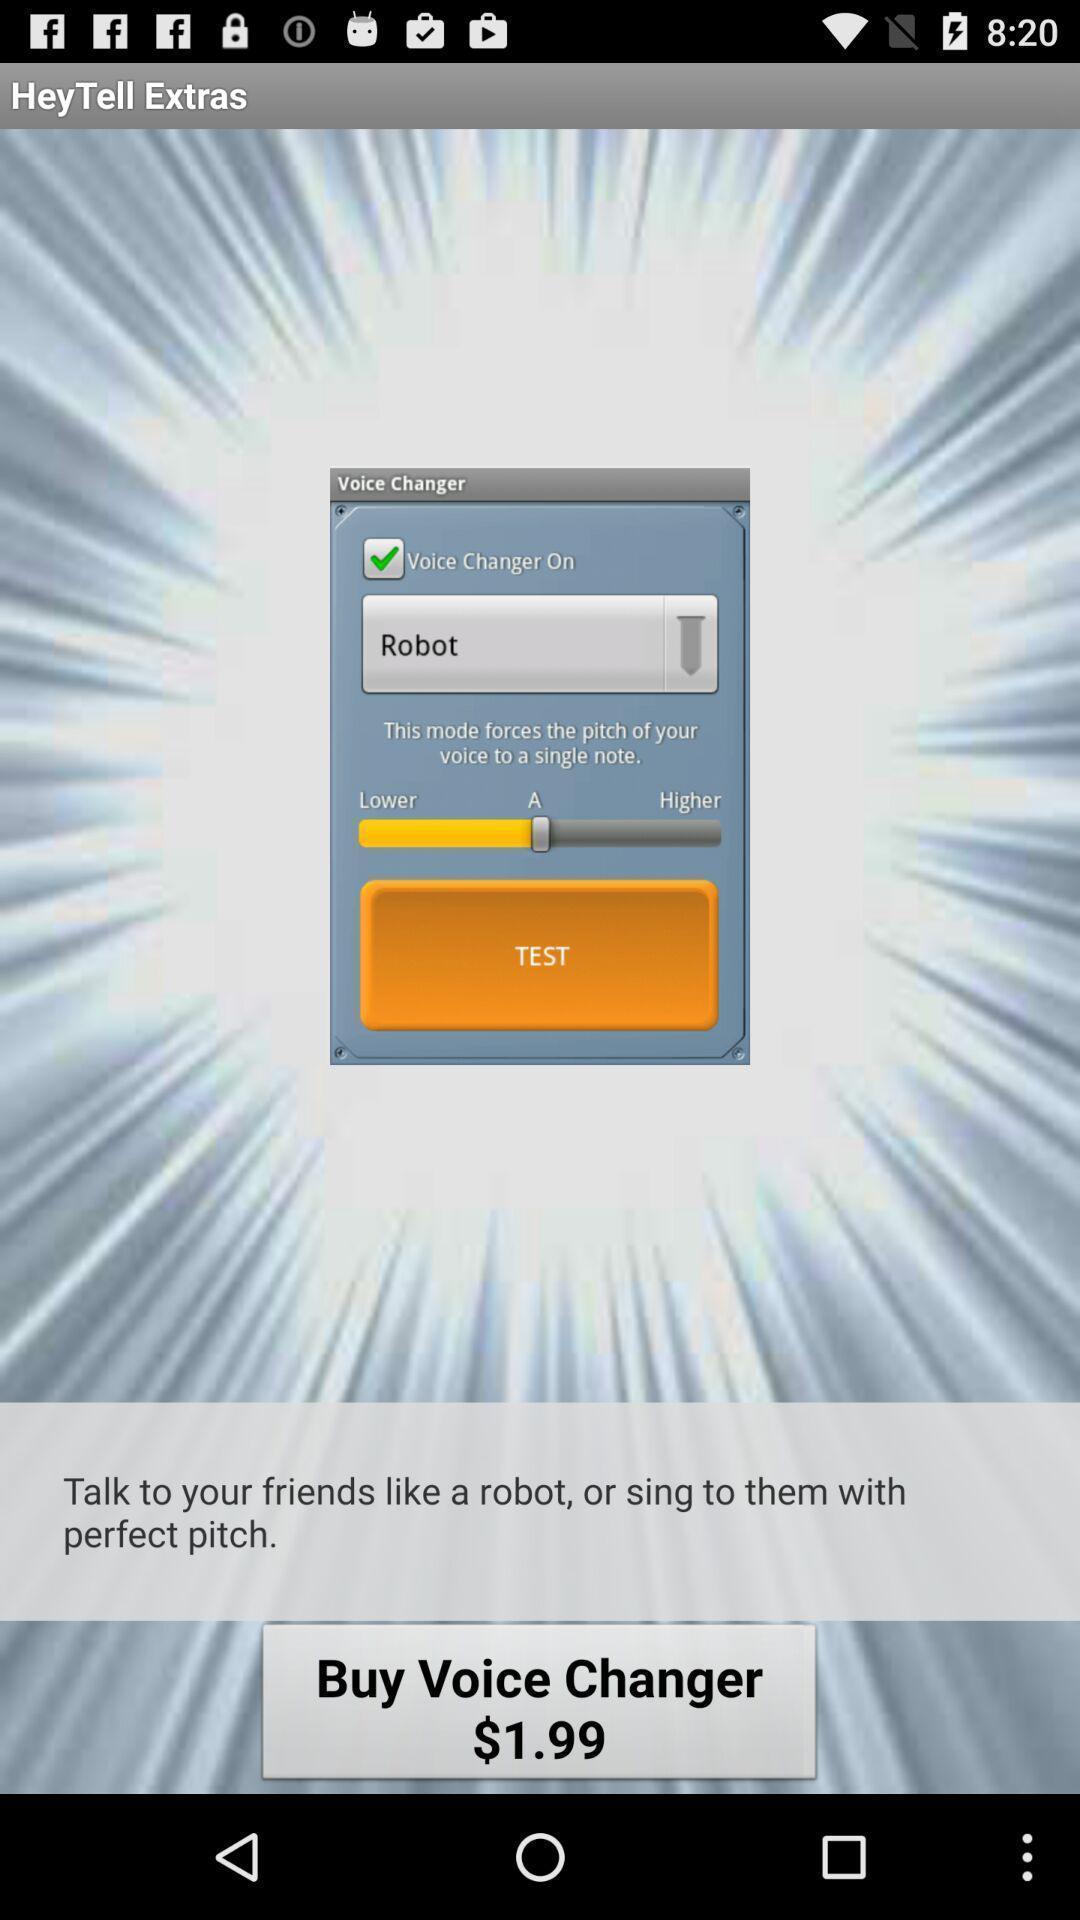Summarize the information in this screenshot. Screen displaying information about the messenger application. 